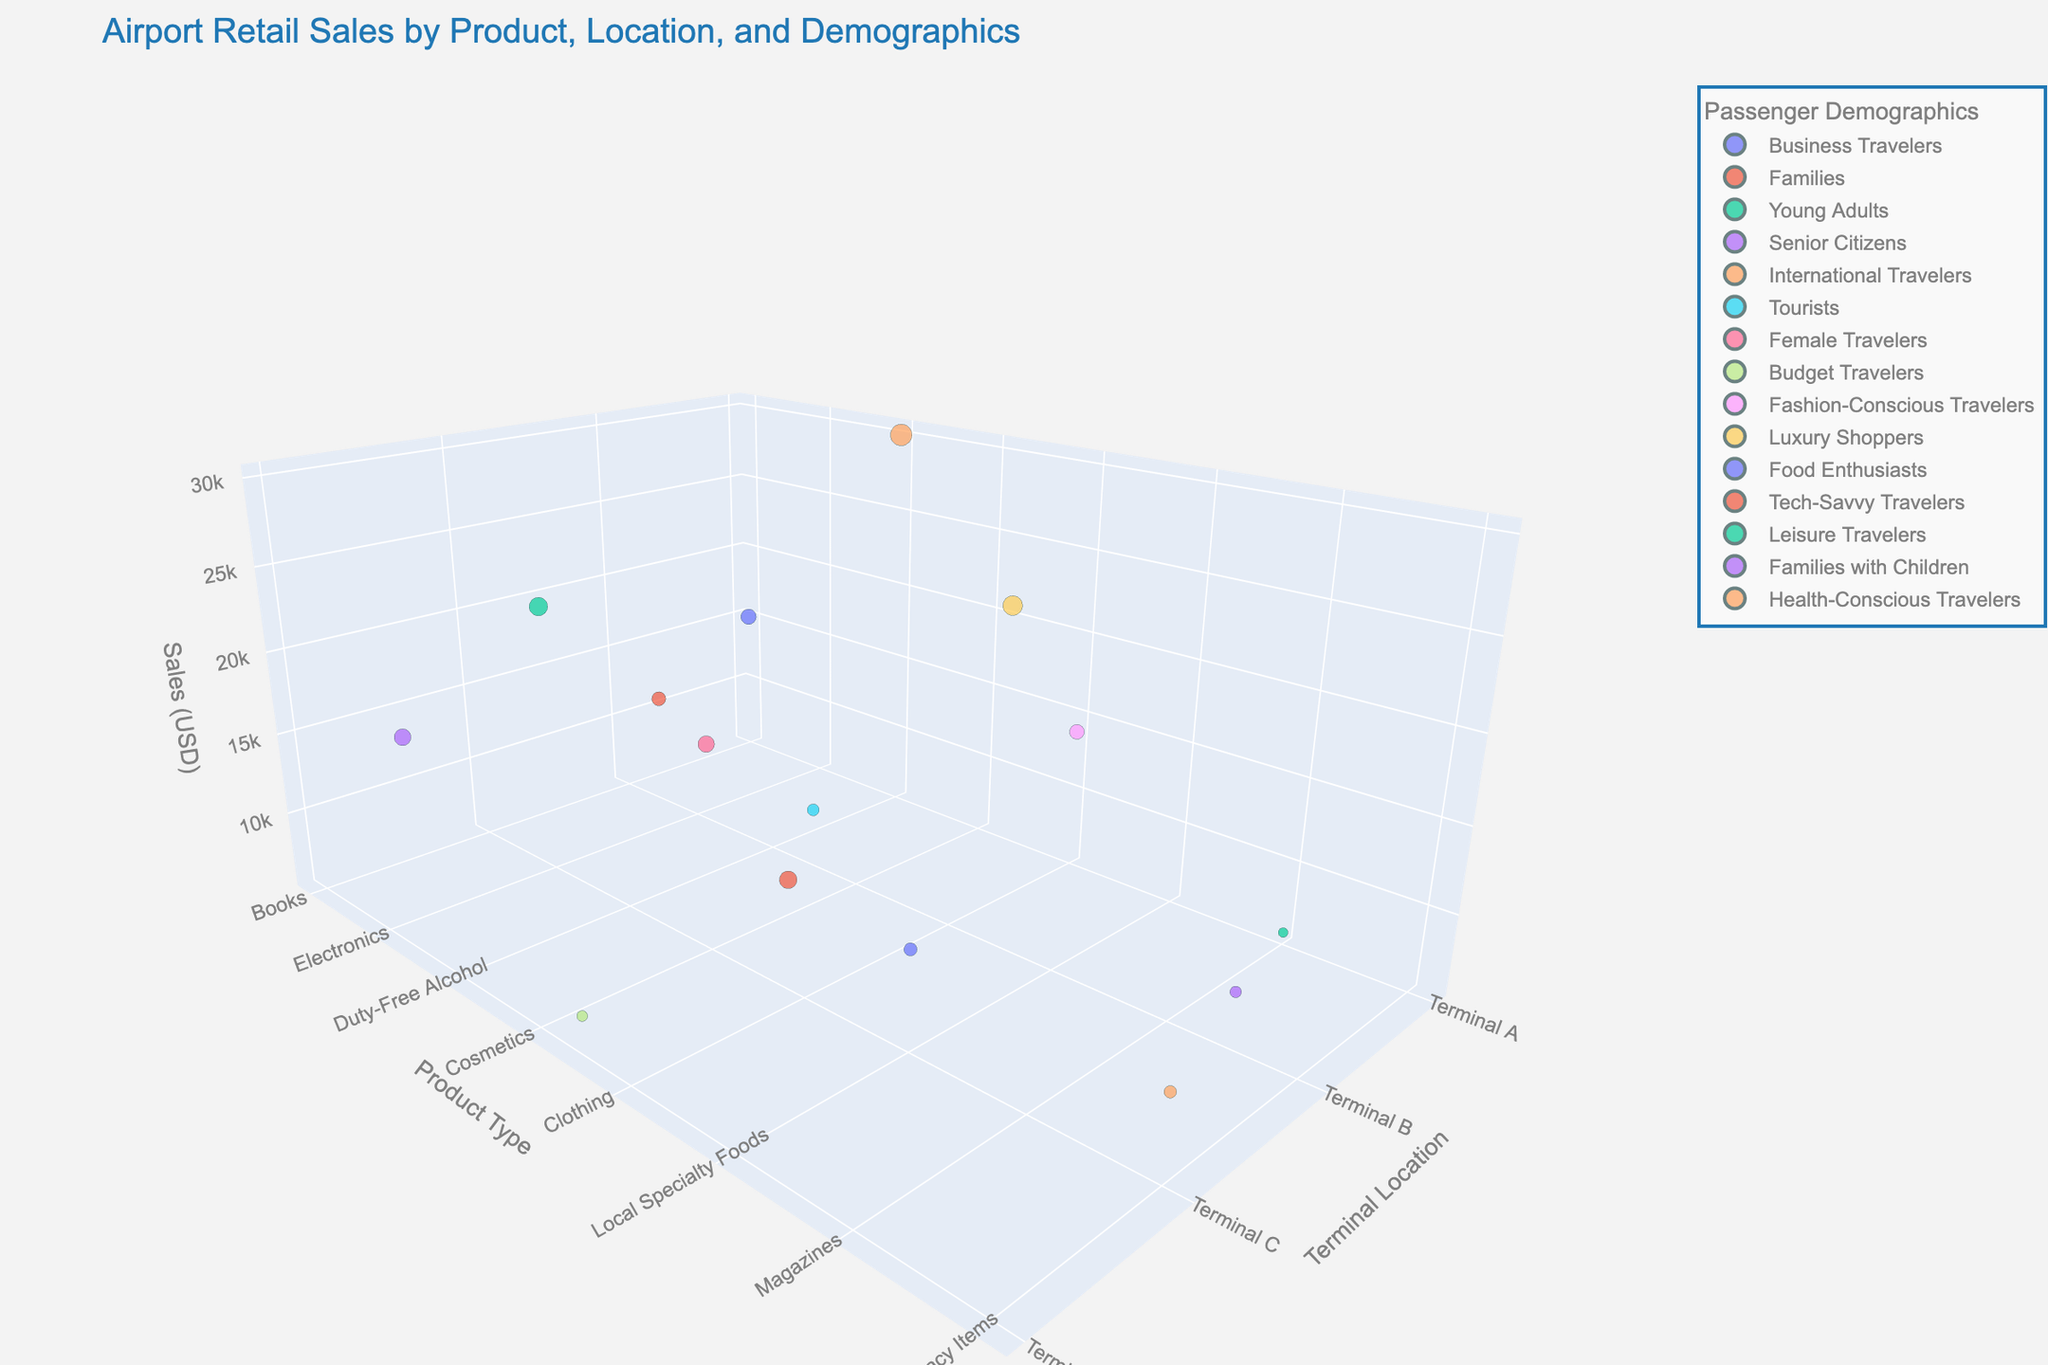Which Terminal Location has the highest sales? By looking at the 'Sales (USD)' dimension and locating the highest point on the z-axis, it is seen that Terminal A has the highest value for 'Duty-Free Alcohol.'
Answer: Terminal A Which product type has the lowest sales? By identifying the lowest point on the 'Sales (USD)' z-axis, it is clear that 'Magazines' has the lowest sales.
Answer: Magazines Which passenger demographic has the highest sales? Comparing the sales values for different passenger demographics, 'International Travelers' has the highest sales associated with 'Duty-Free Alcohol.'
Answer: International Travelers What is the total sales for items sold in Terminal B? Summing up sales for all the items in Terminal B: 12500 (Snacks) + 9000 (Souvenirs) + 25000 (Jewelry) + 8500 (Toys) = 55000 USD.
Answer: 55000 USD Which Terminal Location has the most diverse product offerings? By counting the number of unique product types, Terminal B has the highest variety: Snacks, Souvenirs, Jewelry, and Toys (4 types).
Answer: Terminal B Between 'Luxury Goods' and 'Tech Gadgets', which one has higher sales, and by how much? 'Tech Gadgets' in Terminal D generates 20000 USD, while 'Luxury Goods' in Terminal D generates 18000 USD. The difference is 20000 - 18000 = 2000 USD.
Answer: Tech Gadgets, 2000 USD Which Passenger Demographic generates the least amount of sales? By identifying the lowest sales value among demographics, 'Leisure Travelers' for 'Magazines' generate the least: 6000 USD.
Answer: Leisure Travelers What is the average sales for products sold in Terminal C? Summing up sales in Terminal C: 22000 (Electronics) + 17500 (Cosmetics) + 11000 (Local Specialty Foods) + 10000 (Pharmacy Items) = 60500 USD. Average is 60500 / 4 = 15125 USD.
Answer: 15125 USD Which product type generates the highest average sales across all terminals? Summing sales for each product type across terminals and dividing by the number of terminals. The highest is 'Duty-Free Alcohol' with one value of 30000, making it the highest single-point average.
Answer: Duty-Free Alcohol What is the combined sales of 'Cosmetics' and 'Clothing' and which terminal are they located in? Adding sales for 'Cosmetics' in Terminal C (17500 USD) and 'Clothing' in Terminal A (14000 USD), results in 17500 + 14000 = 31500 USD. They are in Terminals C and A, respectively.
Answer: 31500 USD, Terminal C & Terminal A 